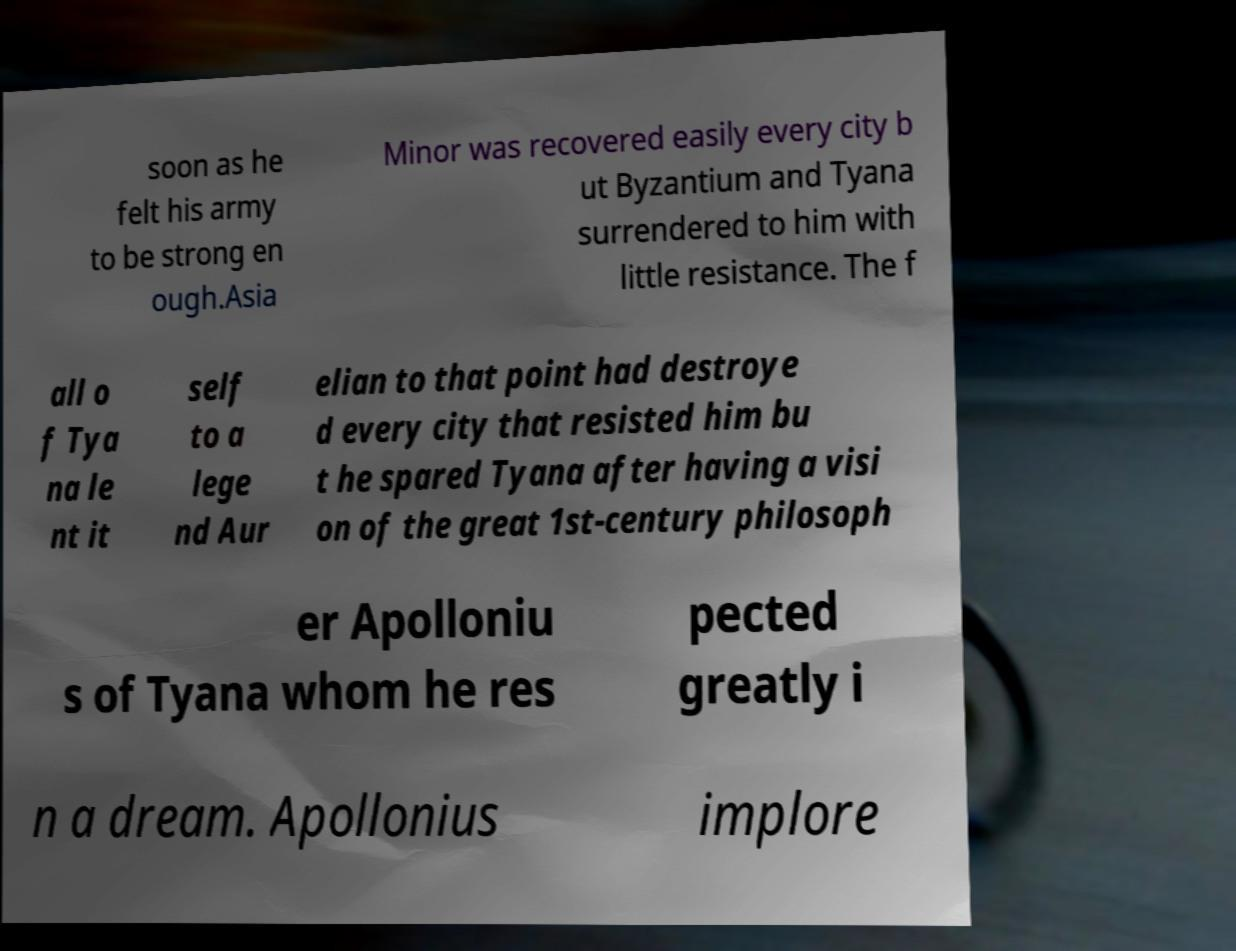Can you accurately transcribe the text from the provided image for me? soon as he felt his army to be strong en ough.Asia Minor was recovered easily every city b ut Byzantium and Tyana surrendered to him with little resistance. The f all o f Tya na le nt it self to a lege nd Aur elian to that point had destroye d every city that resisted him bu t he spared Tyana after having a visi on of the great 1st-century philosoph er Apolloniu s of Tyana whom he res pected greatly i n a dream. Apollonius implore 